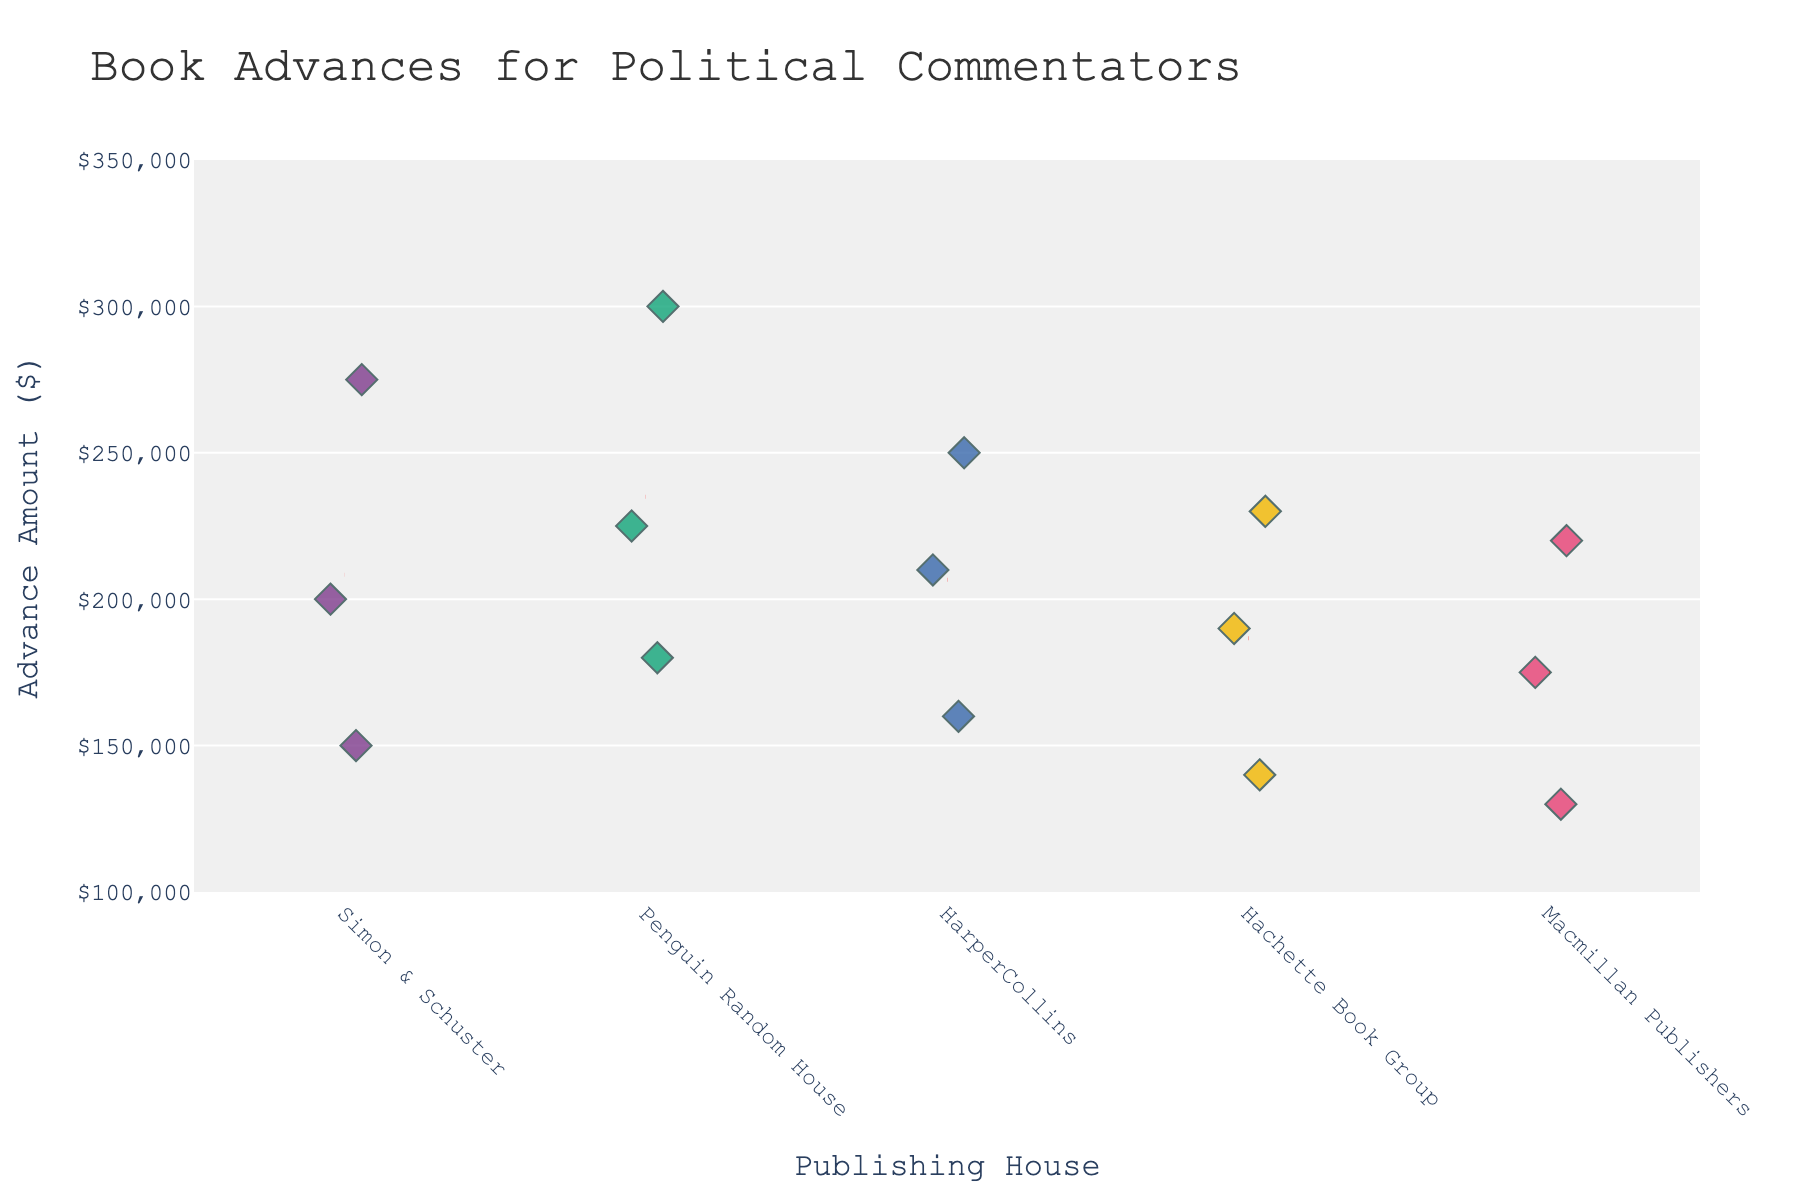What is the range of the advance amounts for Penguin Random House? The advance amounts for Penguin Random House are 180000, 225000, and 300000. The range is the difference between the highest and lowest values: 300000 - 180000 = 120000.
Answer: 120000 Which publishing house offers the highest book advance? The highest advance amount visible is 300000, which is offered by Penguin Random House.
Answer: Penguin Random House How many data points are there for HarperCollins? There are three data points for HarperCollins: 160000, 210000, and 250000.
Answer: 3 Which publishing house has the lowest average book advance? Summing the advance amounts for each publishing house and dividing by the number of data points: 
Simon & Schuster: (150000 + 200000 + 275000) / 3 = 208333.33 
Penguin Random House: (180000 + 225000 + 300000) / 3 = 235000 
HarperCollins: (160000 + 210000 + 250000) / 3 = 206666.67 
Hachette Book Group: (140000 + 190000 + 230000) / 3 = 186666.67 
Macmillan Publishers: (130000 + 175000 + 220000) / 3 = 175000 
Macmillan Publishers has the lowest average advance.
Answer: Macmillan Publishers What is the highest advance amount offered by Simon & Schuster? The highest advance amount for Simon & Schuster is 275000.
Answer: 275000 Which publishing house has the most data points above 200000? Counting the data points above 200000 for each publishing house: 
Simon & Schuster: 200000, 275000 (2 points) 
Penguin Random House: 225000, 300000 (2 points) 
HarperCollins: 210000, 250000 (2 points) 
Hachette Book Group: 230000 (1 point) 
Macmillan Publishers: 220000 (1 point) 
Simon & Schuster, Penguin Random House, and HarperCollins all have the most data points above 200000 with 2 each.
Answer: Simon & Schuster, Penguin Random House, HarperCollins What is the median advance amount for Hachette Book Group? The advance amounts for Hachette Book Group are 140000, 190000, and 230000. Arranged in order: 140000, 190000, 230000. The median is the middle value: 190000.
Answer: 190000 How do the mean advance amounts between Penguin Random House and HarperCollins compare? Calculating the means:
Penguin Random House: (180000 + 225000 + 300000) / 3 = 235000
HarperCollins: (160000 + 210000 + 250000) / 3 = 206666.67
Penguin Random House has a higher mean advance amount than HarperCollins.
Answer: Penguin Random House What appears to be the most common advance amount range overall? The majority of the data points across all publishing houses seem to fall between 150000 and 250000.
Answer: 150000 to 250000 Are there any publishing houses without any data points below 150000? The advance amounts below 150000 are for Hachette Book Group (140000) and Macmillan Publishers (130000). This means Simon & Schuster, Penguin Random House, and HarperCollins do not have any data points below 150000.
Answer: Simon & Schuster, Penguin Random House, HarperCollins 